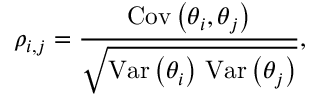Convert formula to latex. <formula><loc_0><loc_0><loc_500><loc_500>\rho _ { i , j } = \frac { C o v \left ( \theta _ { i } , \theta _ { j } \right ) } { \sqrt { V a r \left ( \theta _ { i } \right ) \, V a r \left ( \theta _ { j } \right ) } } ,</formula> 